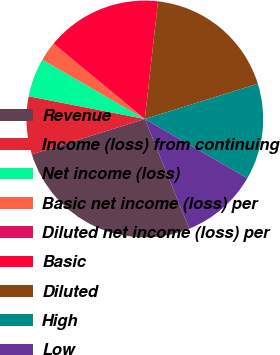<chart> <loc_0><loc_0><loc_500><loc_500><pie_chart><fcel>Revenue<fcel>Income (loss) from continuing<fcel>Net income (loss)<fcel>Basic net income (loss) per<fcel>Diluted net income (loss) per<fcel>Basic<fcel>Diluted<fcel>High<fcel>Low<nl><fcel>26.3%<fcel>7.9%<fcel>5.27%<fcel>2.64%<fcel>0.01%<fcel>15.78%<fcel>18.41%<fcel>13.15%<fcel>10.53%<nl></chart> 